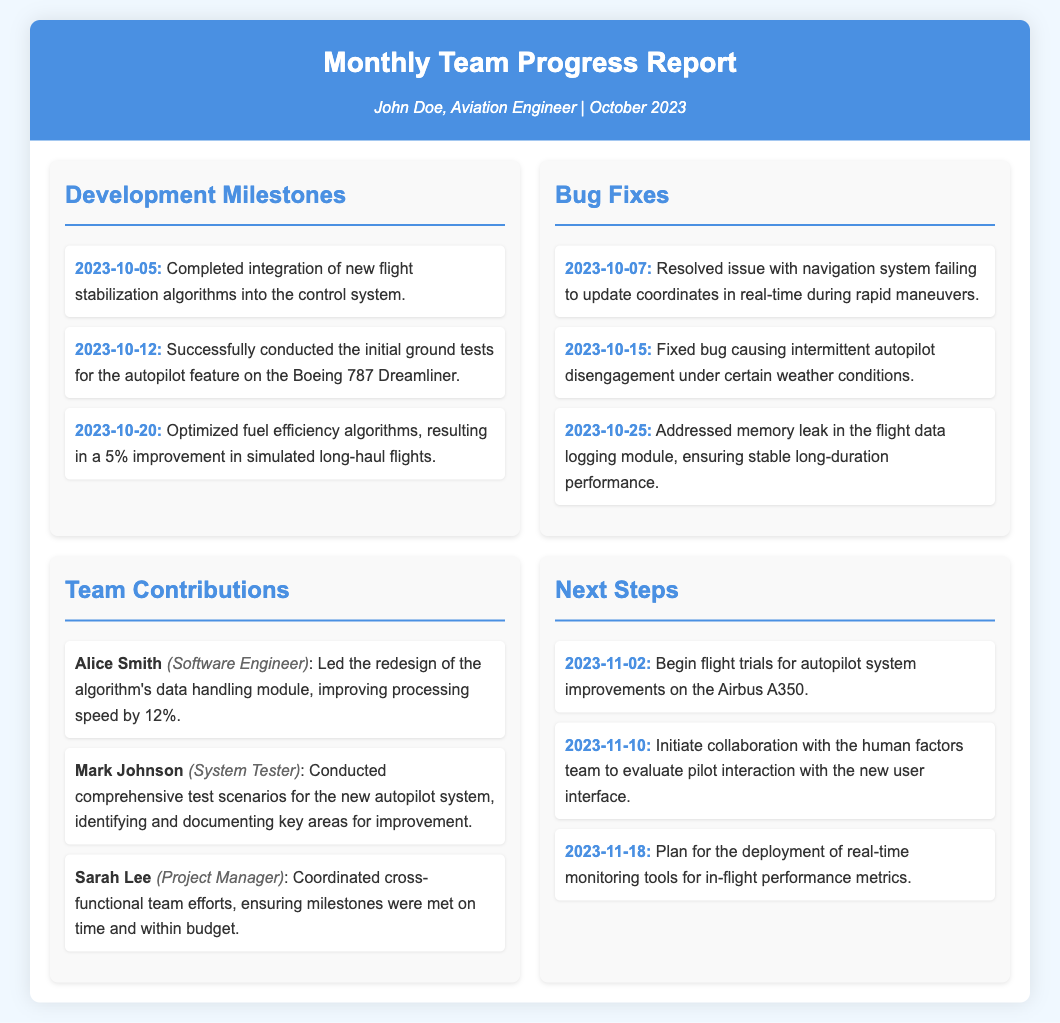What is the date of the completion of the flight stabilization algorithms? The specific date mentioned in the document for the completion of the integration of new flight stabilization algorithms is 2023-10-05.
Answer: 2023-10-05 What improvement in fuel efficiency was achieved? The document states there was a 5% improvement in simulated long-haul flights due to optimized fuel efficiency algorithms.
Answer: 5% Who resolved the navigation system issue? The document does not specify a name for the team member who resolved the navigation system issue; it only states the date of resolution.
Answer: Not specified What role does Alice Smith hold? The report documents Alice Smith's role as a Software Engineer.
Answer: Software Engineer Which aircraft is set for flight trials on November 2nd? According to the document, the Airbus A350 is scheduled for flight trials on November 2nd.
Answer: Airbus A350 What bug was addressed on October 25th? The document indicates that a memory leak in the flight data logging module was addressed.
Answer: Memory leak How many milestones were achieved in October? By counting the milestones listed, there are three milestones mentioned for the month of October.
Answer: 3 What team member conducted test scenarios for the autopilot system? Mark Johnson is mentioned as the team member who conducted comprehensive test scenarios for the new autopilot system.
Answer: Mark Johnson What is the next step after evaluating the user interface? The document states that the deployment of real-time monitoring tools for in-flight performance metrics is planned next.
Answer: Deployment of real-time monitoring tools 